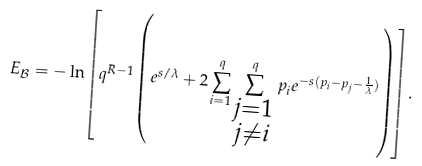<formula> <loc_0><loc_0><loc_500><loc_500>E _ { \mathcal { B } } = - \ln \left [ q ^ { R - 1 } \left ( e ^ { s / \lambda } + 2 \sum ^ { q } _ { i = 1 } \sum ^ { q } _ { \substack { j = 1 \\ j \ne i } } p _ { i } e ^ { - s ( p _ { i } - p _ { j } - \frac { 1 } { \lambda } ) } \right ) \right ] .</formula> 